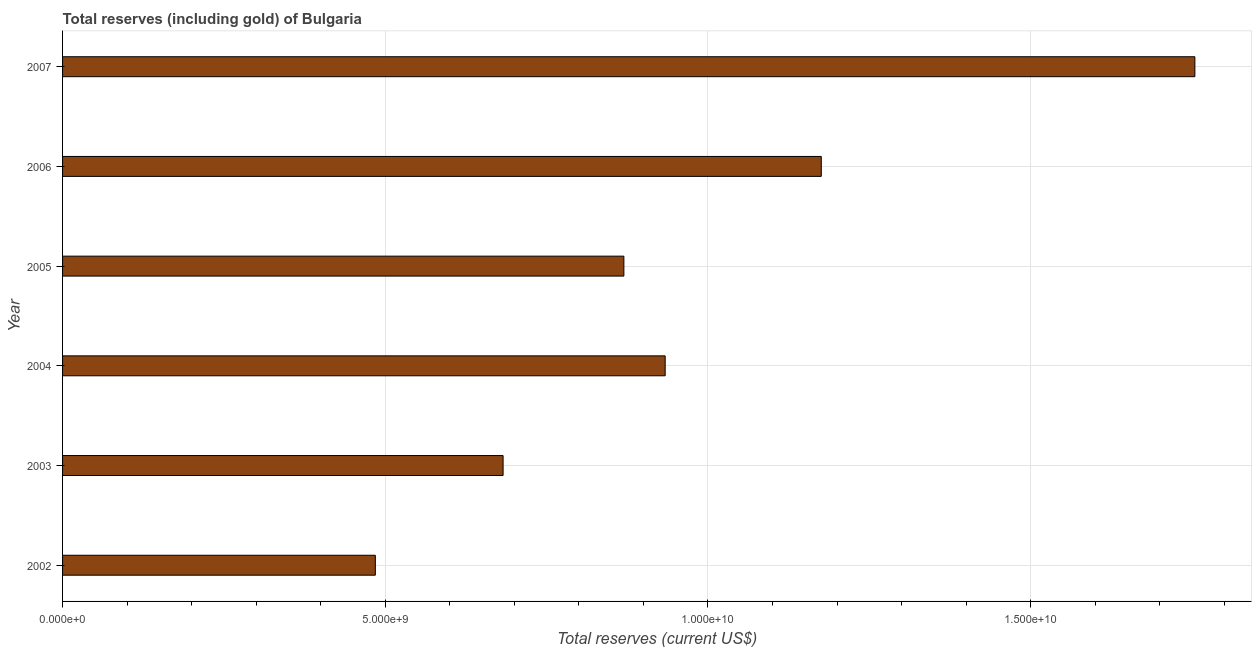Does the graph contain any zero values?
Provide a succinct answer. No. What is the title of the graph?
Your answer should be compact. Total reserves (including gold) of Bulgaria. What is the label or title of the X-axis?
Your response must be concise. Total reserves (current US$). What is the label or title of the Y-axis?
Your response must be concise. Year. What is the total reserves (including gold) in 2002?
Offer a terse response. 4.85e+09. Across all years, what is the maximum total reserves (including gold)?
Offer a very short reply. 1.75e+1. Across all years, what is the minimum total reserves (including gold)?
Offer a terse response. 4.85e+09. What is the sum of the total reserves (including gold)?
Offer a terse response. 5.90e+1. What is the difference between the total reserves (including gold) in 2003 and 2007?
Your answer should be compact. -1.07e+1. What is the average total reserves (including gold) per year?
Provide a succinct answer. 9.83e+09. What is the median total reserves (including gold)?
Make the answer very short. 9.02e+09. In how many years, is the total reserves (including gold) greater than 4000000000 US$?
Keep it short and to the point. 6. What is the ratio of the total reserves (including gold) in 2004 to that in 2006?
Offer a very short reply. 0.79. Is the total reserves (including gold) in 2003 less than that in 2005?
Make the answer very short. Yes. Is the difference between the total reserves (including gold) in 2003 and 2004 greater than the difference between any two years?
Offer a very short reply. No. What is the difference between the highest and the second highest total reserves (including gold)?
Give a very brief answer. 5.79e+09. What is the difference between the highest and the lowest total reserves (including gold)?
Your response must be concise. 1.27e+1. How many bars are there?
Your response must be concise. 6. What is the difference between two consecutive major ticks on the X-axis?
Offer a very short reply. 5.00e+09. Are the values on the major ticks of X-axis written in scientific E-notation?
Give a very brief answer. Yes. What is the Total reserves (current US$) of 2002?
Keep it short and to the point. 4.85e+09. What is the Total reserves (current US$) of 2003?
Offer a very short reply. 6.83e+09. What is the Total reserves (current US$) of 2004?
Keep it short and to the point. 9.34e+09. What is the Total reserves (current US$) in 2005?
Your answer should be compact. 8.70e+09. What is the Total reserves (current US$) in 2006?
Make the answer very short. 1.18e+1. What is the Total reserves (current US$) of 2007?
Make the answer very short. 1.75e+1. What is the difference between the Total reserves (current US$) in 2002 and 2003?
Your answer should be very brief. -1.98e+09. What is the difference between the Total reserves (current US$) in 2002 and 2004?
Give a very brief answer. -4.49e+09. What is the difference between the Total reserves (current US$) in 2002 and 2005?
Your answer should be compact. -3.85e+09. What is the difference between the Total reserves (current US$) in 2002 and 2006?
Provide a short and direct response. -6.91e+09. What is the difference between the Total reserves (current US$) in 2002 and 2007?
Give a very brief answer. -1.27e+1. What is the difference between the Total reserves (current US$) in 2003 and 2004?
Offer a very short reply. -2.51e+09. What is the difference between the Total reserves (current US$) in 2003 and 2005?
Your response must be concise. -1.87e+09. What is the difference between the Total reserves (current US$) in 2003 and 2006?
Your answer should be compact. -4.93e+09. What is the difference between the Total reserves (current US$) in 2003 and 2007?
Provide a succinct answer. -1.07e+1. What is the difference between the Total reserves (current US$) in 2004 and 2005?
Provide a short and direct response. 6.40e+08. What is the difference between the Total reserves (current US$) in 2004 and 2006?
Ensure brevity in your answer.  -2.42e+09. What is the difference between the Total reserves (current US$) in 2004 and 2007?
Give a very brief answer. -8.21e+09. What is the difference between the Total reserves (current US$) in 2005 and 2006?
Make the answer very short. -3.06e+09. What is the difference between the Total reserves (current US$) in 2005 and 2007?
Give a very brief answer. -8.85e+09. What is the difference between the Total reserves (current US$) in 2006 and 2007?
Offer a terse response. -5.79e+09. What is the ratio of the Total reserves (current US$) in 2002 to that in 2003?
Ensure brevity in your answer.  0.71. What is the ratio of the Total reserves (current US$) in 2002 to that in 2004?
Your answer should be very brief. 0.52. What is the ratio of the Total reserves (current US$) in 2002 to that in 2005?
Provide a succinct answer. 0.56. What is the ratio of the Total reserves (current US$) in 2002 to that in 2006?
Offer a very short reply. 0.41. What is the ratio of the Total reserves (current US$) in 2002 to that in 2007?
Give a very brief answer. 0.28. What is the ratio of the Total reserves (current US$) in 2003 to that in 2004?
Your answer should be very brief. 0.73. What is the ratio of the Total reserves (current US$) in 2003 to that in 2005?
Your response must be concise. 0.79. What is the ratio of the Total reserves (current US$) in 2003 to that in 2006?
Give a very brief answer. 0.58. What is the ratio of the Total reserves (current US$) in 2003 to that in 2007?
Your answer should be compact. 0.39. What is the ratio of the Total reserves (current US$) in 2004 to that in 2005?
Give a very brief answer. 1.07. What is the ratio of the Total reserves (current US$) in 2004 to that in 2006?
Provide a short and direct response. 0.79. What is the ratio of the Total reserves (current US$) in 2004 to that in 2007?
Ensure brevity in your answer.  0.53. What is the ratio of the Total reserves (current US$) in 2005 to that in 2006?
Provide a short and direct response. 0.74. What is the ratio of the Total reserves (current US$) in 2005 to that in 2007?
Provide a short and direct response. 0.5. What is the ratio of the Total reserves (current US$) in 2006 to that in 2007?
Ensure brevity in your answer.  0.67. 